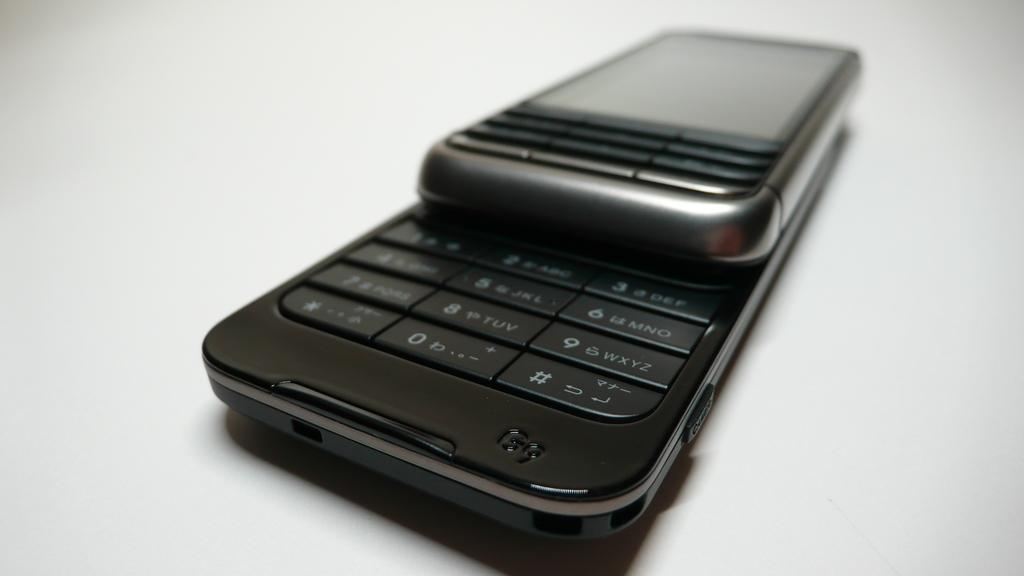<image>
Summarize the visual content of the image. Slide cell phone that show the numbers 1 through 9 and the 0 keys. 